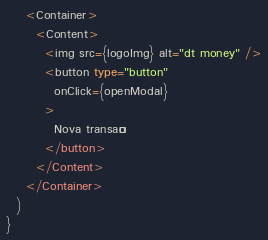Convert code to text. <code><loc_0><loc_0><loc_500><loc_500><_TypeScript_>    <Container>
      <Content>
        <img src={logoImg} alt="dt money" />
        <button type="button" 
          onClick={openModal}
        >
          Nova transação
        </button>
      </Content>
    </Container>
  )
}</code> 